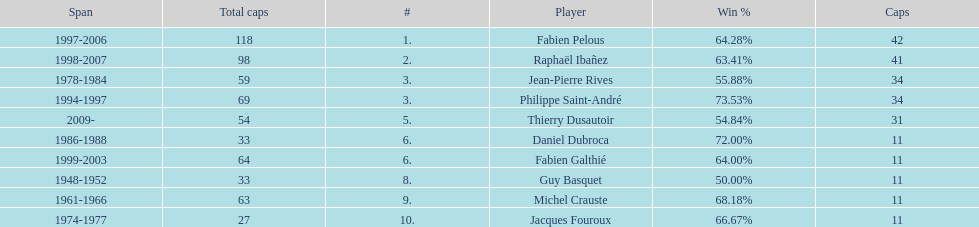Which captain served the least amount of time? Daniel Dubroca. 